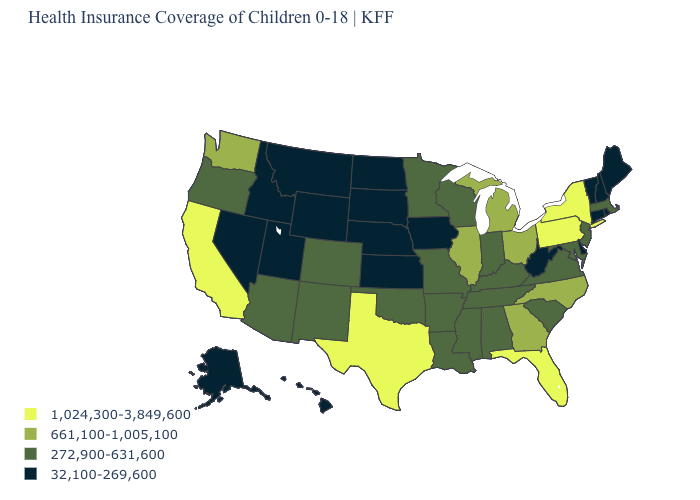Name the states that have a value in the range 1,024,300-3,849,600?
Be succinct. California, Florida, New York, Pennsylvania, Texas. What is the value of Maine?
Be succinct. 32,100-269,600. What is the value of Arizona?
Concise answer only. 272,900-631,600. Which states have the highest value in the USA?
Keep it brief. California, Florida, New York, Pennsylvania, Texas. Name the states that have a value in the range 1,024,300-3,849,600?
Keep it brief. California, Florida, New York, Pennsylvania, Texas. Name the states that have a value in the range 272,900-631,600?
Keep it brief. Alabama, Arizona, Arkansas, Colorado, Indiana, Kentucky, Louisiana, Maryland, Massachusetts, Minnesota, Mississippi, Missouri, New Jersey, New Mexico, Oklahoma, Oregon, South Carolina, Tennessee, Virginia, Wisconsin. Which states have the lowest value in the USA?
Write a very short answer. Alaska, Connecticut, Delaware, Hawaii, Idaho, Iowa, Kansas, Maine, Montana, Nebraska, Nevada, New Hampshire, North Dakota, Rhode Island, South Dakota, Utah, Vermont, West Virginia, Wyoming. What is the value of West Virginia?
Quick response, please. 32,100-269,600. Name the states that have a value in the range 661,100-1,005,100?
Write a very short answer. Georgia, Illinois, Michigan, North Carolina, Ohio, Washington. Does North Dakota have the highest value in the USA?
Be succinct. No. What is the lowest value in the South?
Answer briefly. 32,100-269,600. What is the value of Missouri?
Concise answer only. 272,900-631,600. Is the legend a continuous bar?
Concise answer only. No. Name the states that have a value in the range 1,024,300-3,849,600?
Keep it brief. California, Florida, New York, Pennsylvania, Texas. What is the value of Iowa?
Answer briefly. 32,100-269,600. 